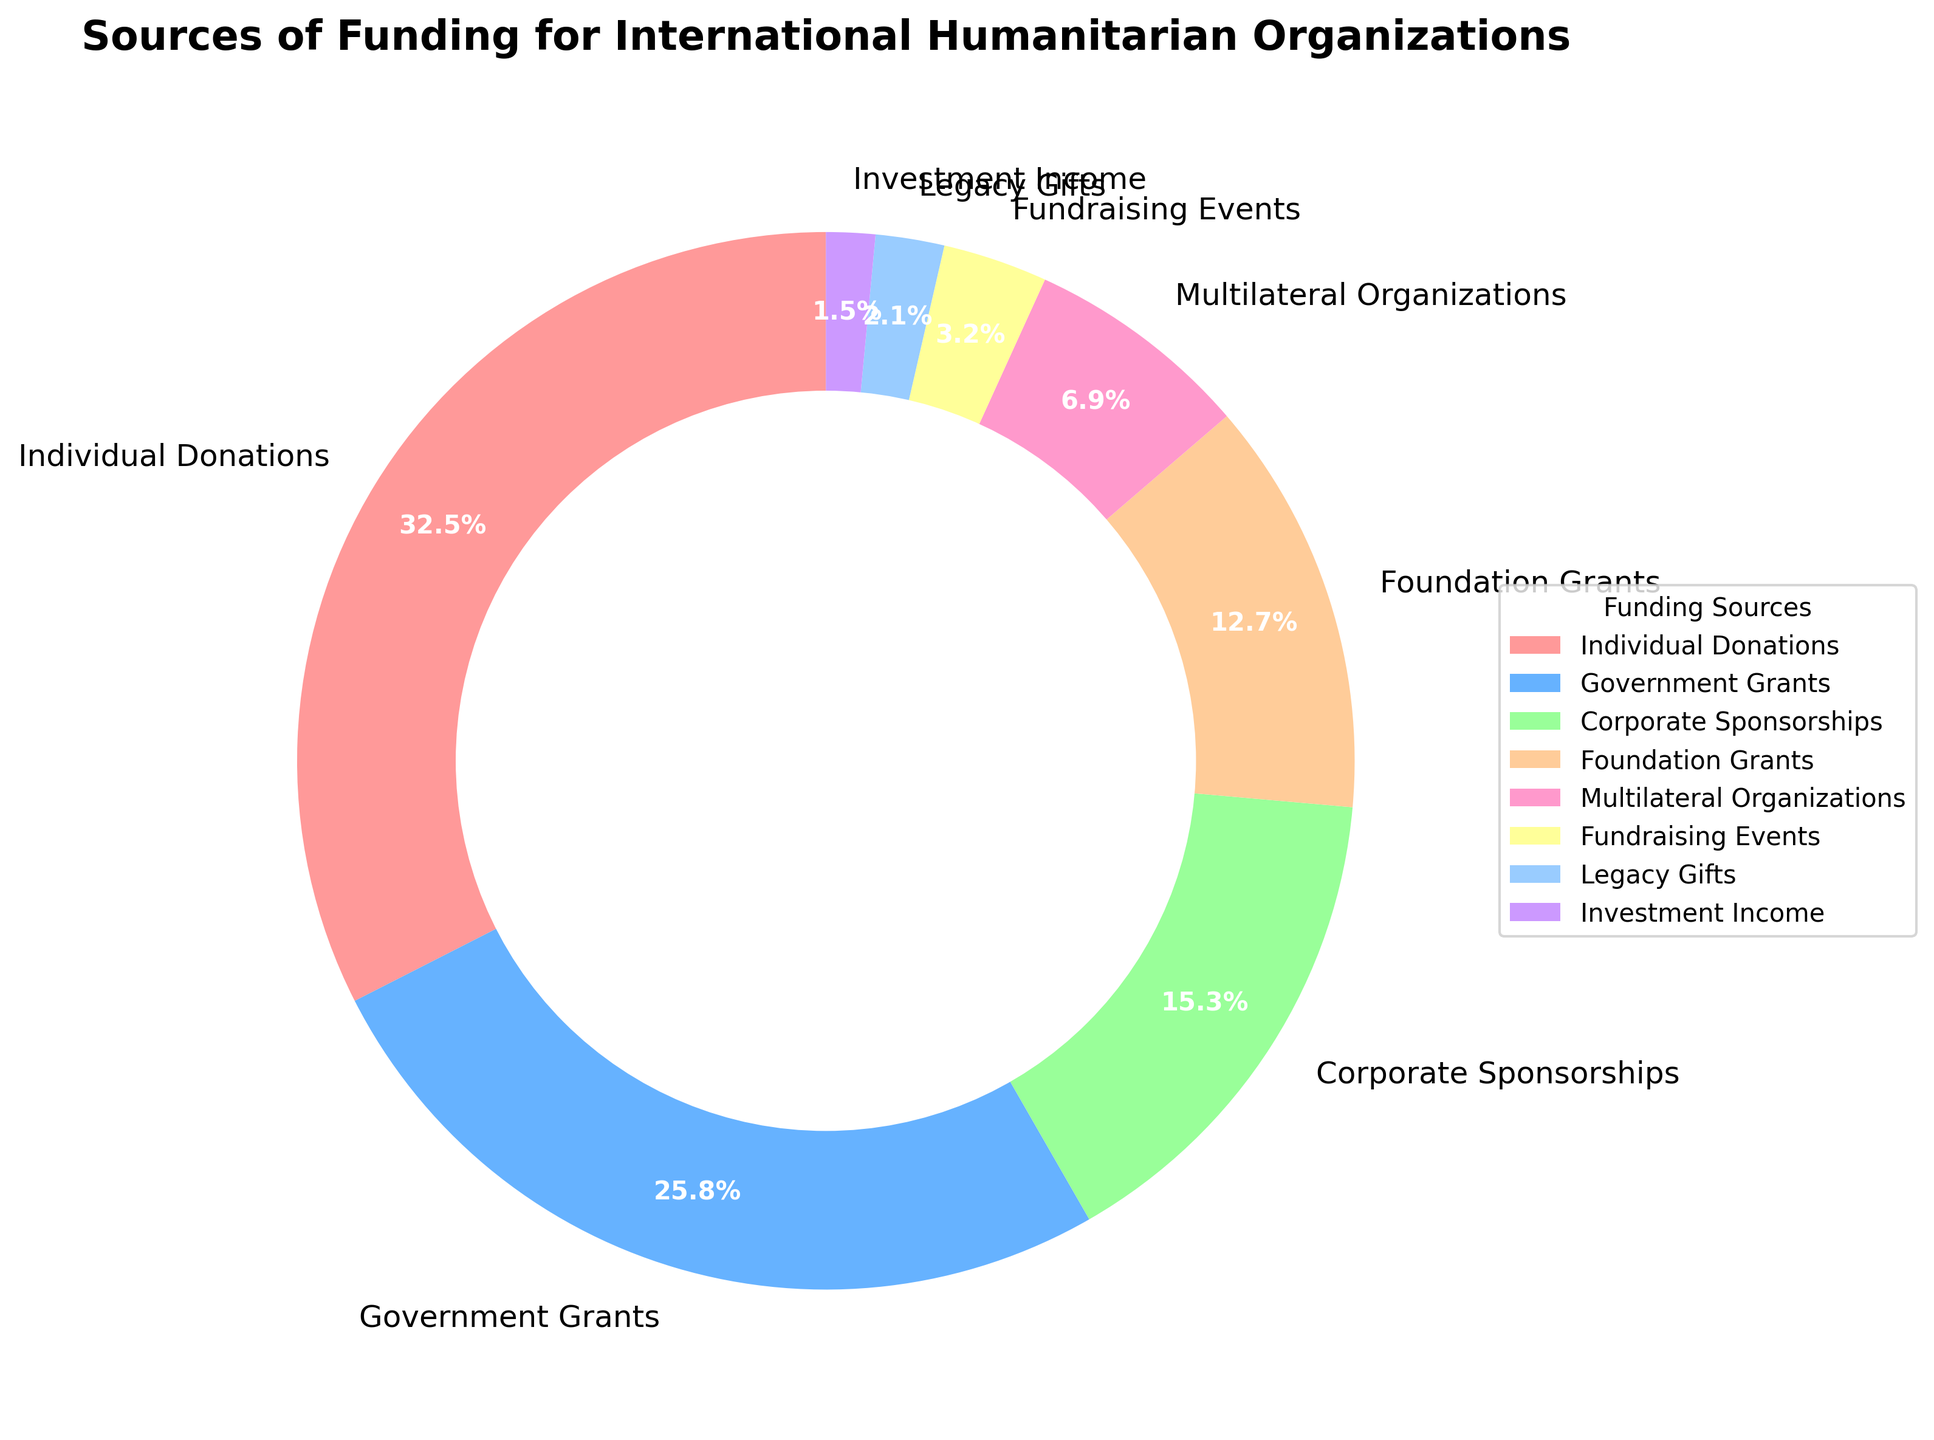Which funding source contributes the highest percentage? The pie chart shows the slices of various funding sources and their corresponding percentages. Individual Donations has the largest slice, labeled with 32.5%.
Answer: Individual Donations What is the combined percentage of Government Grants and Corporate Sponsorships? The percentages for Government Grants and Corporate Sponsorships are 25.8% and 15.3%, respectively. Summing these values gives 25.8 + 15.3 = 41.1%.
Answer: 41.1% How much more does Foundation Grants contribute compared to Fundraising Events? Foundation Grants contribute 12.7% and Fundraising Events contribute 3.2%. The difference is 12.7 - 3.2 = 9.5%.
Answer: 9.5% Which funding source contributes the smallest percentage? The smallest slice on the pie chart, labeled with 1.5%, corresponds to Investment Income.
Answer: Investment Income Is the percentage contribution of Individual Donations more than twice that of Multilateral Organizations? Individual Donations contribute 32.5% and Multilateral Organizations contribute 6.9%. Twice 6.9% is 13.8%. Since 32.5% is greater than 13.8%, the answer is yes.
Answer: Yes What is the combined percentage contribution of the three smallest funding sources? The three smallest funding sources are Fundraising Events (3.2%), Legacy Gifts (2.1%), and Investment Income (1.5%). Summing these values gives 3.2 + 2.1 + 1.5 = 6.8%.
Answer: 6.8% Which funding sources contribute a lower percentage than Government Grants? Government Grants contribute 25.8%. The sources contributing less are Corporate Sponsorships (15.3%), Foundation Grants (12.7%), Multilateral Organizations (6.9%), Fundraising Events (3.2%), Legacy Gifts (2.1%), and Investment Income (1.5%).
Answer: Corporate Sponsorships, Foundation Grants, Multilateral Organizations, Fundraising Events, Legacy Gifts, Investment Income How much more do Individual Donations contribute than Corporate Sponsorships? Individual Donations contribute 32.5% and Corporate Sponsorships contribute 15.3%. The difference is 32.5 - 15.3 = 17.2%.
Answer: 17.2% Are there any funding sources that contribute an equal or greater percentage than Foundation Grants? Foundation Grants contribute 12.7%. The sources contributing an equal or greater percentage are Individual Donations (32.5%), Government Grants (25.8%), and Corporate Sponsorships (15.3%).
Answer: Individual Donations, Government Grants, Corporate Sponsorships 